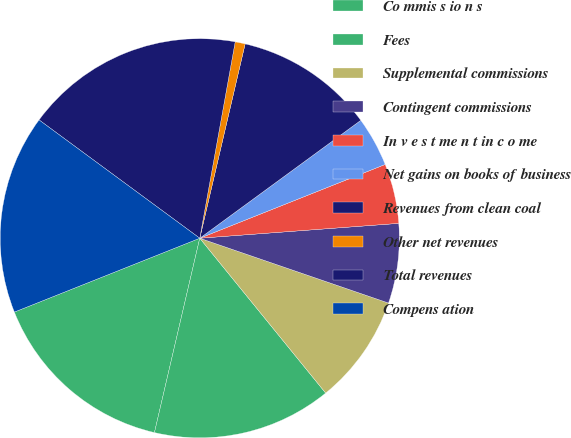<chart> <loc_0><loc_0><loc_500><loc_500><pie_chart><fcel>Co mmis s io n s<fcel>Fees<fcel>Supplemental commissions<fcel>Contingent commissions<fcel>In v e s t me n t in c o me<fcel>Net gains on books of business<fcel>Revenues from clean coal<fcel>Other net revenues<fcel>Total revenues<fcel>Compens ation<nl><fcel>15.32%<fcel>14.51%<fcel>8.87%<fcel>6.45%<fcel>4.84%<fcel>4.03%<fcel>11.29%<fcel>0.81%<fcel>17.74%<fcel>16.13%<nl></chart> 